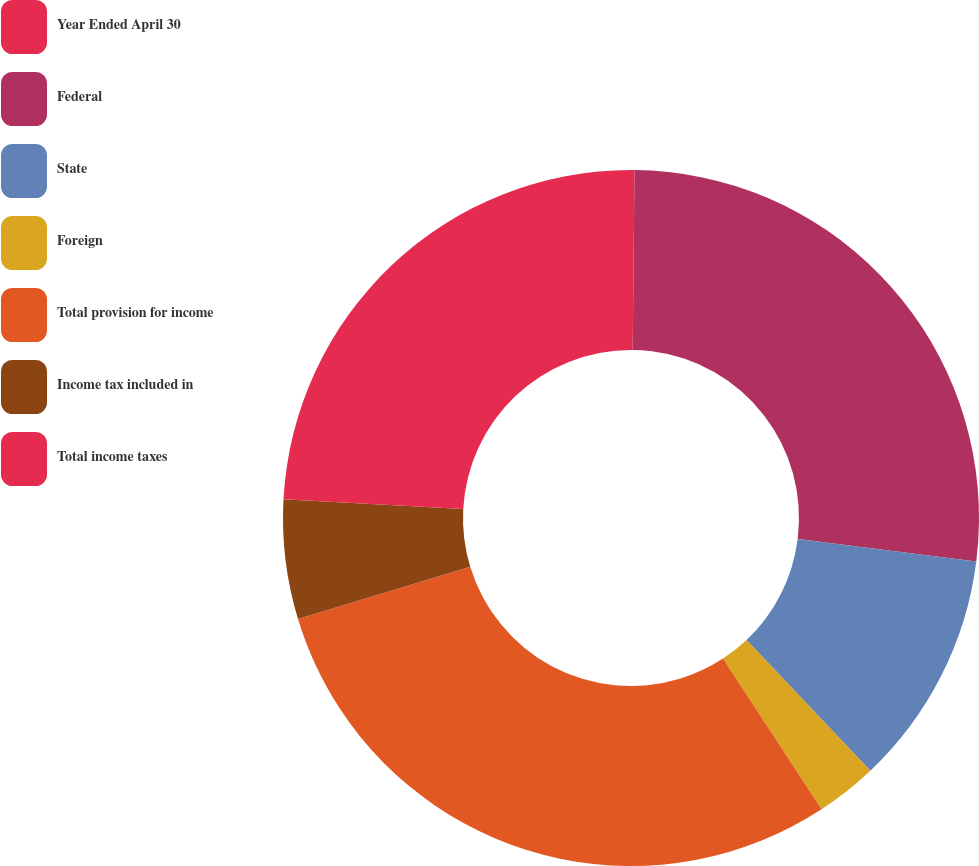Convert chart. <chart><loc_0><loc_0><loc_500><loc_500><pie_chart><fcel>Year Ended April 30<fcel>Federal<fcel>State<fcel>Foreign<fcel>Total provision for income<fcel>Income tax included in<fcel>Total income taxes<nl><fcel>0.16%<fcel>26.83%<fcel>10.94%<fcel>2.85%<fcel>29.53%<fcel>5.55%<fcel>24.14%<nl></chart> 